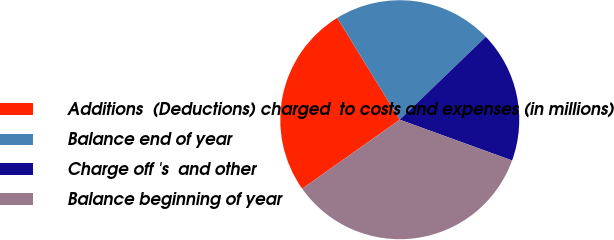Convert chart. <chart><loc_0><loc_0><loc_500><loc_500><pie_chart><fcel>Additions  (Deductions) charged  to costs and expenses (in millions)<fcel>Balance end of year<fcel>Charge off 's  and other<fcel>Balance beginning of year<nl><fcel>26.03%<fcel>21.57%<fcel>17.74%<fcel>34.66%<nl></chart> 